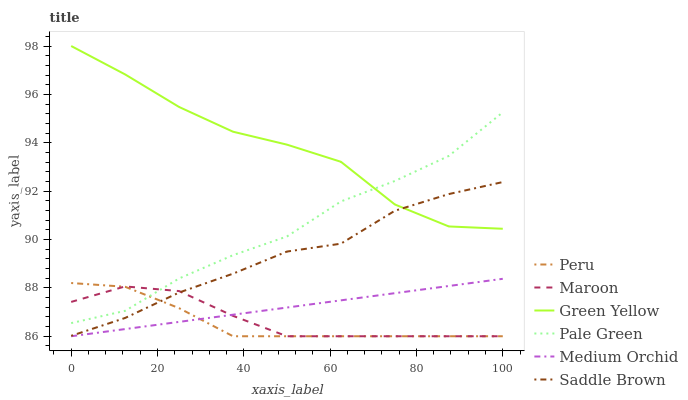Does Peru have the minimum area under the curve?
Answer yes or no. Yes. Does Green Yellow have the maximum area under the curve?
Answer yes or no. Yes. Does Maroon have the minimum area under the curve?
Answer yes or no. No. Does Maroon have the maximum area under the curve?
Answer yes or no. No. Is Medium Orchid the smoothest?
Answer yes or no. Yes. Is Green Yellow the roughest?
Answer yes or no. Yes. Is Maroon the smoothest?
Answer yes or no. No. Is Maroon the roughest?
Answer yes or no. No. Does Medium Orchid have the lowest value?
Answer yes or no. Yes. Does Pale Green have the lowest value?
Answer yes or no. No. Does Green Yellow have the highest value?
Answer yes or no. Yes. Does Pale Green have the highest value?
Answer yes or no. No. Is Peru less than Green Yellow?
Answer yes or no. Yes. Is Pale Green greater than Medium Orchid?
Answer yes or no. Yes. Does Maroon intersect Peru?
Answer yes or no. Yes. Is Maroon less than Peru?
Answer yes or no. No. Is Maroon greater than Peru?
Answer yes or no. No. Does Peru intersect Green Yellow?
Answer yes or no. No. 